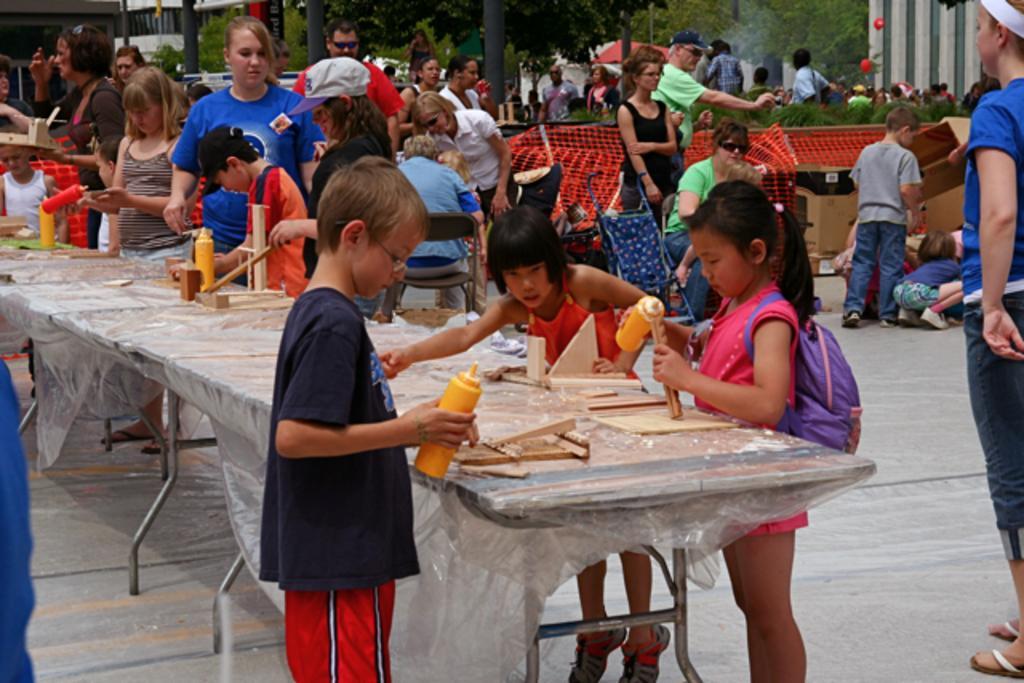Please provide a concise description of this image. There are group of people and there is a table in front of them which has some wooden block on it and there are group of people behind them and there are trees in the background. 